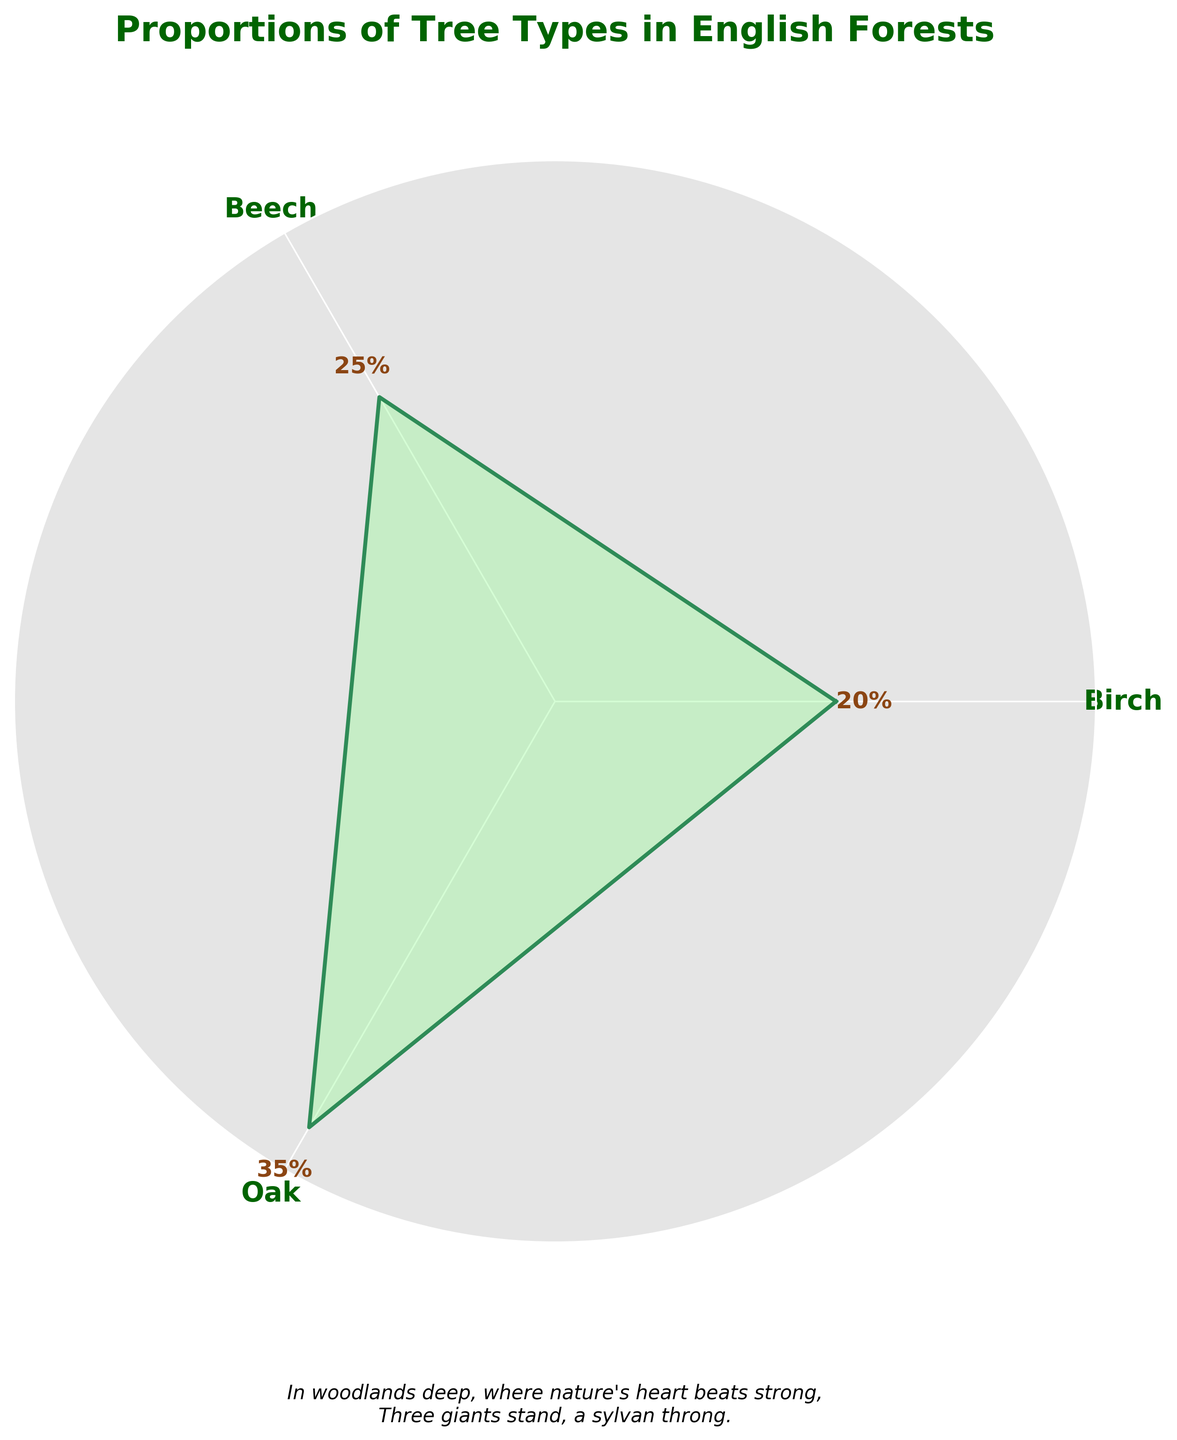What are the three tree types displayed on the chart? The three tree types are labeled on the axis of the rose chart as 'Oak', 'Beech', and 'Pine'.
Answer: Oak, Beech, Pine Which tree type shows the highest proportion in English forests? The 'Oak' section has the highest value reaching up to 35%, indicated by its position on the plot and the proportion label.
Answer: Oak What is the total proportion of Pine and Beech combined? The proportions for Pine and Beech are 20% and 25%. Adding them together gives 20 + 25 = 45%.
Answer: 45% Compare the proportions of Beech and Pine to determine which is greater and by how much. The proportion of Beech is 25%, and for Pine, it is 20%. Subtracting 20 from 25 gives a difference of 5%.
Answer: Beech by 5% What color is used to fill the area of the rose chart? The interior color of the rose chart is a light green shade, which contrasts with the darker border color.
Answer: Light green Looking at the axes labels, how do the text characteristics stand out? The axes labels for the tree types ('Oak', 'Beech', 'Pine') are in bold, green coloring, which makes them prominent and easy to read.
Answer: Bold green What poetic touch is added to the plot below the diagram? A poem is written in italics below the plot that reads, "In woodlands deep, where nature's heart beats strong, Three giants stand, a sylvan throng."
Answer: A poem about woodlands What is the sum of proportions for all tree types shown in the plot? Adding the proportions for Oak (35%), Beech (25%), and Pine (20%) results in a total of 35 + 25 + 20 = 80%.
Answer: 80% What is the title of the rose chart? The title of the plot is displayed at the top as "Proportions of Tree Types in English Forests".
Answer: Proportions of Tree Types in English Forests What is the radial distance or proportion angle of Beech displayed on the chart? The angle corresponding to 'Beech' measures a proportion of 25%, shown as a radial extent along the circle labeled correctly.
Answer: 25% 